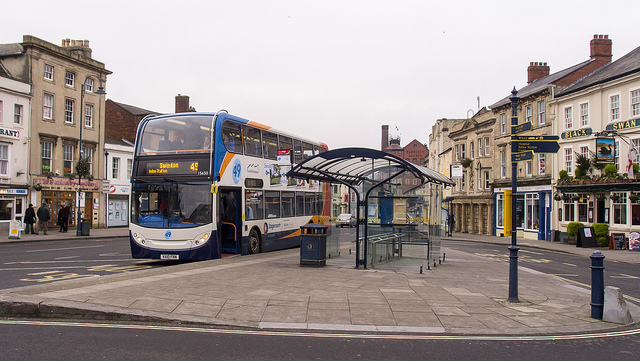Please transcribe the text in this image. 49 SWAN BLACK 